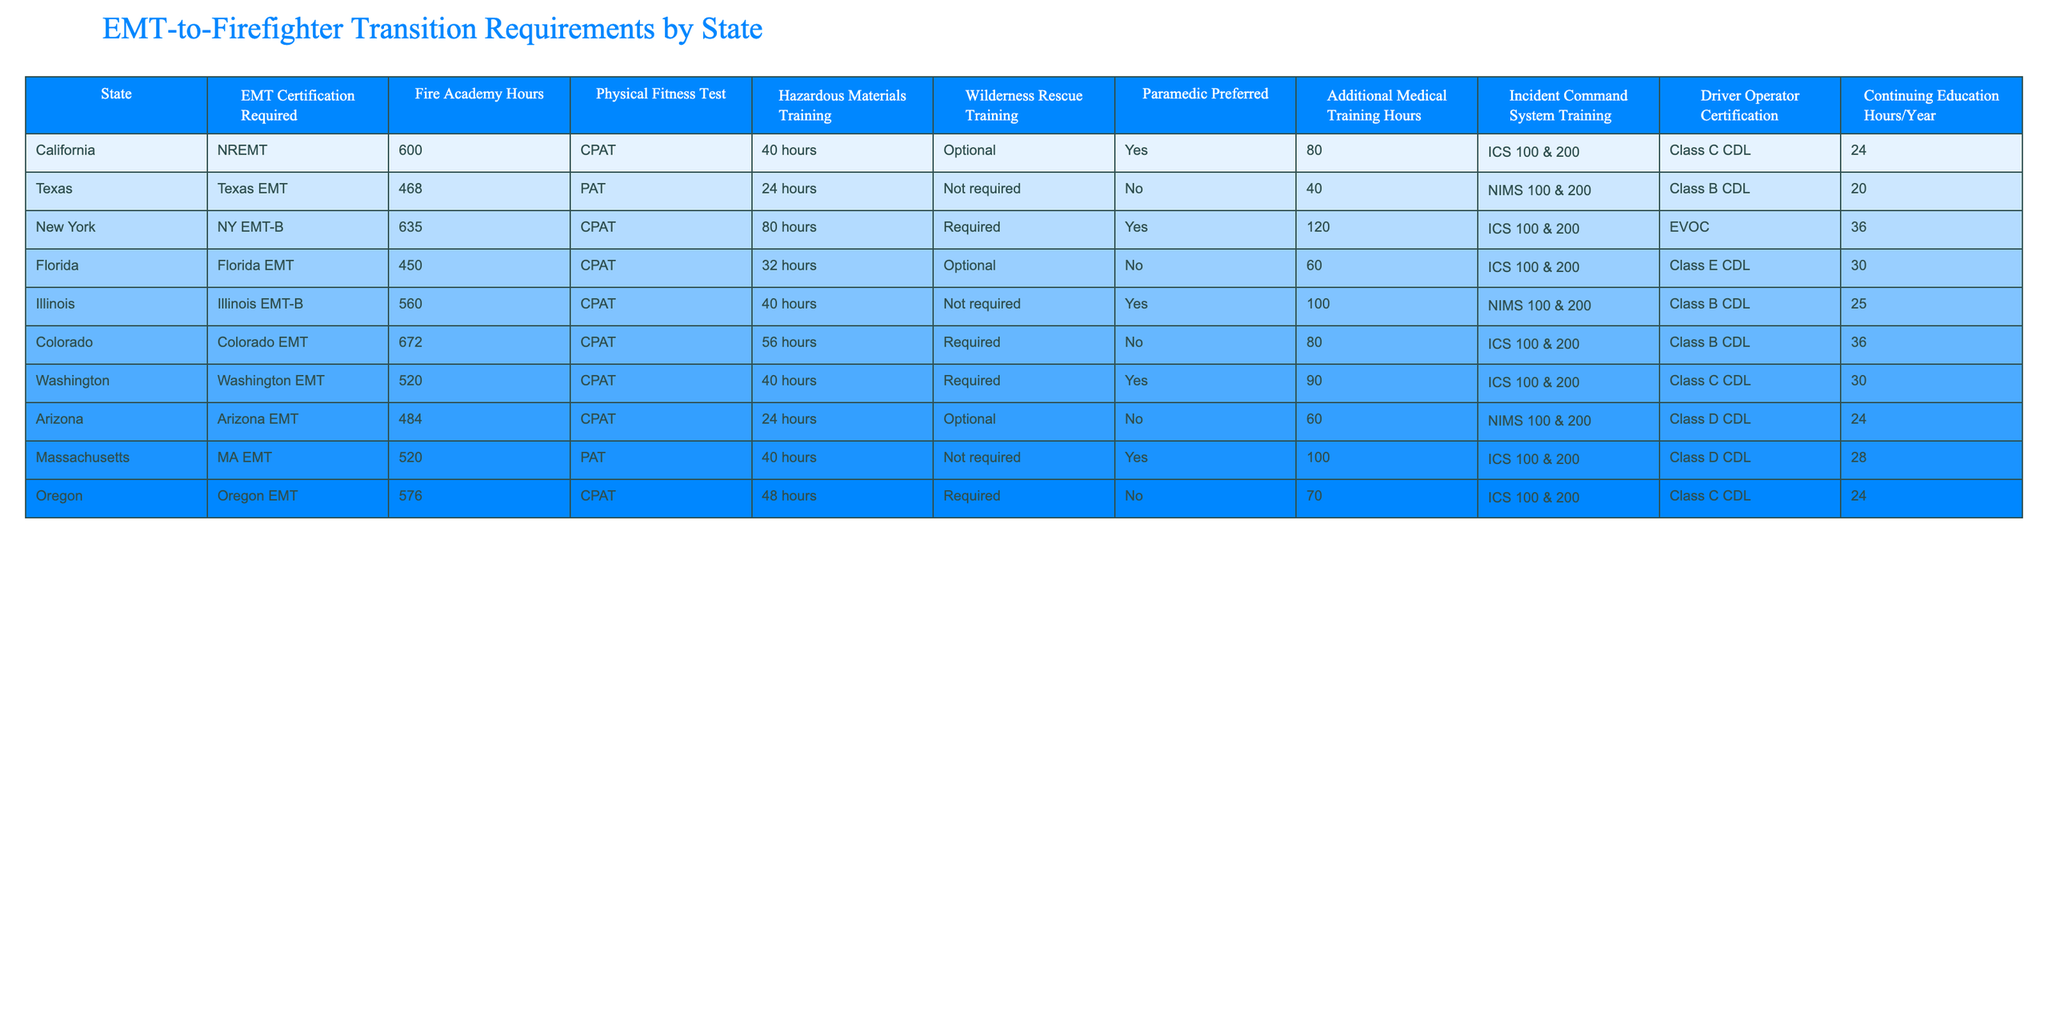What is the EMT certification required in New York? The table indicates that New York requires the NY EMT-B certification for its EMT-to-firefighter transition program.
Answer: NY EMT-B How many hours of fire academy training are required in California? According to the table, California requires 600 hours of fire academy training.
Answer: 600 Is wilderness rescue training mandatory in Illinois? The table shows that wilderness rescue training is noted as "Not required" in Illinois.
Answer: No Which state requires the highest number of additional medical training hours? By examining the table, Colorado requires 80 additional medical training hours, which is the highest among the listed states.
Answer: Colorado What is the average number of continuing education hours per year across all states? The sum of continuing education hours is 24 + 20 + 36 + 30 + 25 + 36 + 30 + 24 + 28 =  273. There are 9 states, thus the average is 273/9 = 30.33, rounded to 30.
Answer: 30 Which two states do not require hazardous materials training? By checking the column for hazardous materials training, Texas and Illinois are the only states listed as "Not required."
Answer: Texas and Illinois What percentage of states require a Class B CDL for driver operator certification? Five out of nine states require a Class B CDL which is calculated as (5/9) * 100 = 55.56%, thus around 56%.
Answer: 56% Was paramedic certification preferred in only some states? Reviewing the table shows that paramedic certification is indicated as "Yes" in New York, Illinois, and California, which confirms it is only preferred in those states.
Answer: Yes What is the total fire academy training hours for all listed states? Adding the fire academy hours: 600 + 468 + 635 + 450 + 560 + 672 + 520 + 484 + 576 = 4935.
Answer: 4935 In which state is the physical fitness test required the longest? The table reveals that New York requires the physical fitness test for 80 hours, while other states require less.
Answer: New York How many states require continuing education hours to be more than 30? By inspecting the table, 5 states (New York, Massachusetts, Colorado, Washington, and Florida) have continuing education requirements greater than 30.
Answer: 5 